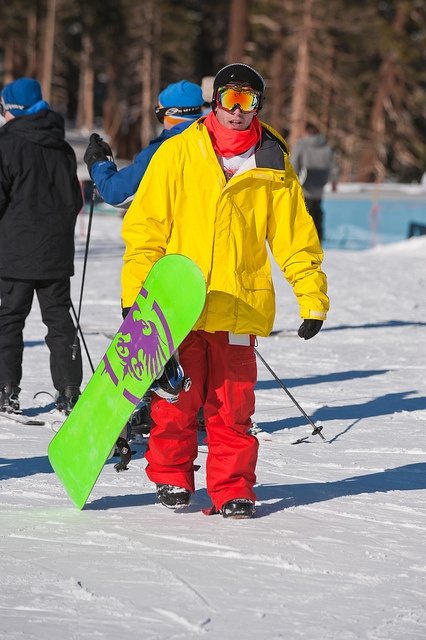Describe the objects in this image and their specific colors. I can see people in black, gold, red, orange, and brown tones, people in black, blue, gray, and darkblue tones, snowboard in black, lime, lightgreen, and purple tones, people in black, blue, gold, and gray tones, and people in black and gray tones in this image. 